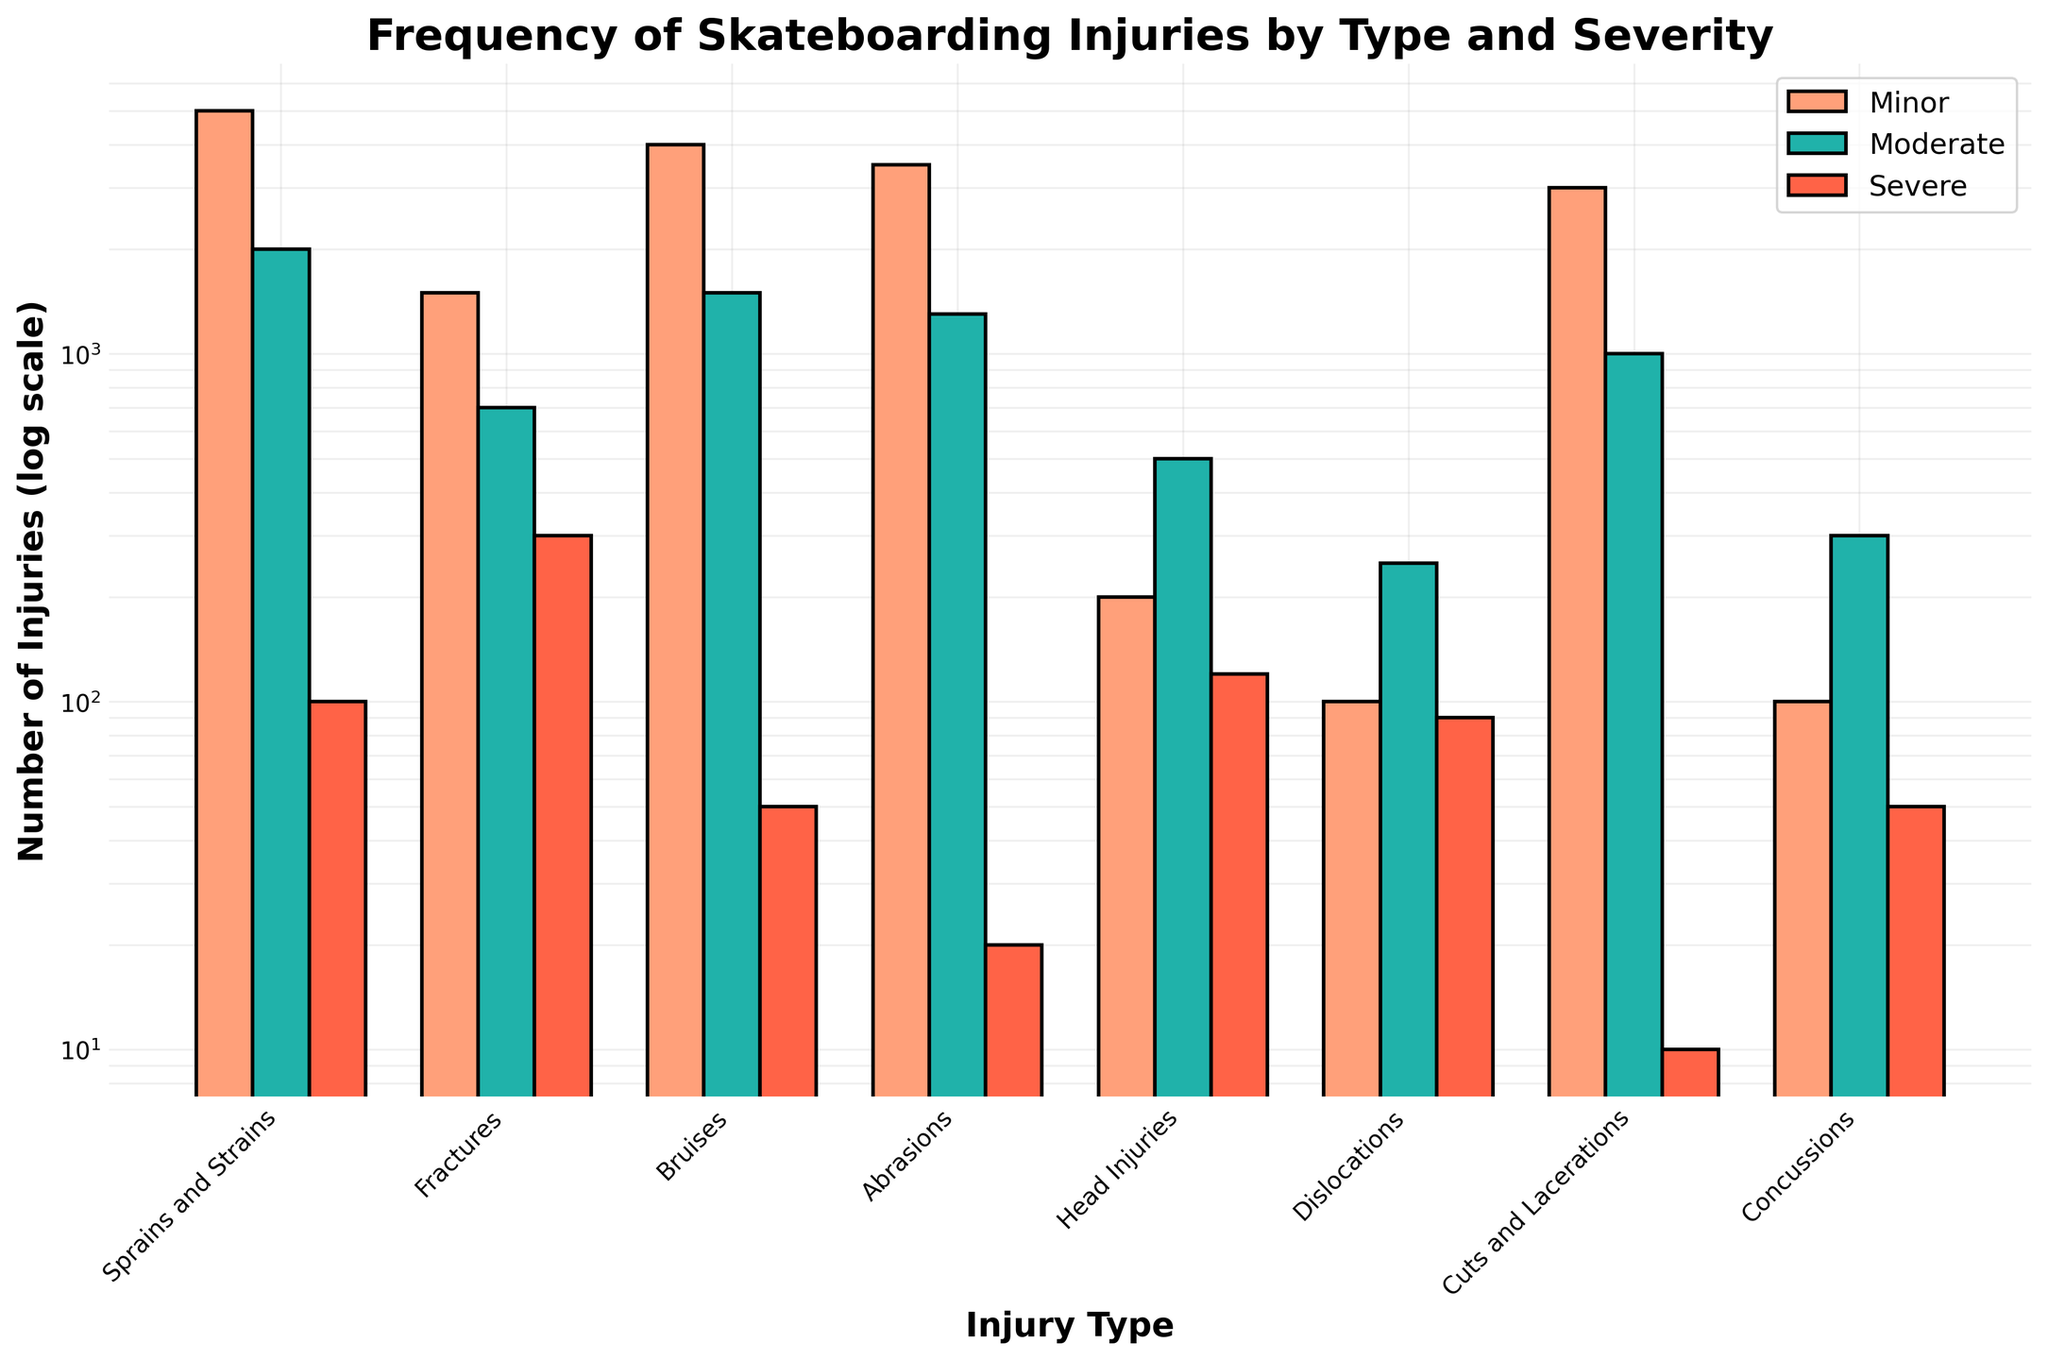What is the title of the figure? The title of the figure is displayed at the top, which typically summarizes the content of the plot. By looking at the plotted figure, you can see the title.
Answer: Frequency of Skateboarding Injuries by Type and Severity What type of injuries has the highest number of minor cases? To determine this, look at the bar corresponding to minor cases for each injury type. The highest bar represents the injury type with the most minor cases.
Answer: Sprains and Strains How many moderate and severe head injuries are there in total? Locate the bars for moderate and severe head injuries, then sum their heights. Based on the log scale, the heights correspond to the given numbers.
Answer: 620 Which type of injury has the smallest number of severe cases? Find the shortest bar in the severe category, which uses the log scale to visually show the smallest value.
Answer: Cuts and Lacerations How do the minor sprains and strains cases compare to minor fractures cases? Compare the height of the bars for minor cases in these two injury types to see which is higher.
Answer: Minor sprains and strains are more frequent than minor fractures What is the difference in the number of minor and severe abrasions? Subtract the value of severe abrasions from the value of minor abrasions to get the difference.
Answer: 3480 What are the three injury types with the lowest number of minor injuries? Look at the minor category and identify the three shortest bars, indicating the lowest values.
Answer: Head Injuries, Dislocations, Concussions Which injury type has a more significant number of injuries, fractures or bruises, regardless of severity? Add the minor, moderate, and severe cases for fractures and for bruises, then compare the sums to determine which is higher.
Answer: Bruises In which injury type are severe injuries almost as frequent as moderate ones? Examine the bars where the heights for moderate and severe injuries are closest to each other.
Answer: Head Injuries How does the log scale affect the interpretation of the injury frequencies? On a log scale, bars showing differences in height represent larger differences in actual values than they would on a linear scale, making it crucial to carefully interpret the relative heights.
Answer: Log scale emphasizes differences at lower injury counts 